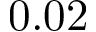Convert formula to latex. <formula><loc_0><loc_0><loc_500><loc_500>0 . 0 2</formula> 